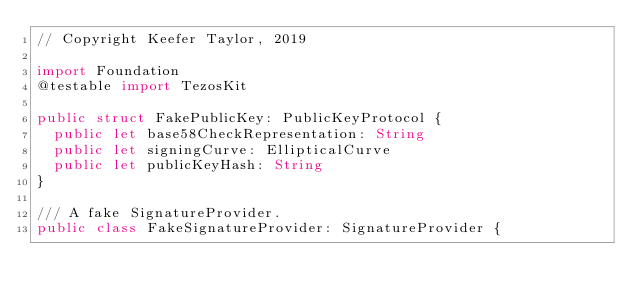Convert code to text. <code><loc_0><loc_0><loc_500><loc_500><_Swift_>// Copyright Keefer Taylor, 2019

import Foundation
@testable import TezosKit

public struct FakePublicKey: PublicKeyProtocol {
  public let base58CheckRepresentation: String
  public let signingCurve: EllipticalCurve
  public let publicKeyHash: String
}

/// A fake SignatureProvider.
public class FakeSignatureProvider: SignatureProvider {</code> 